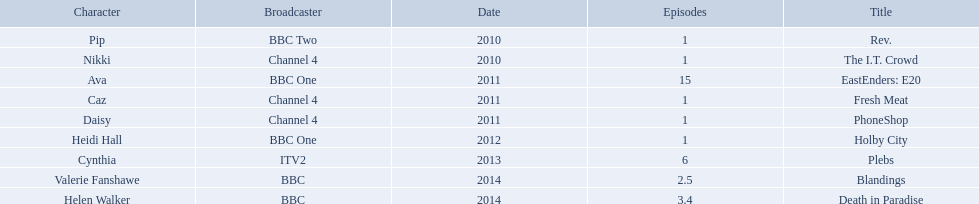What roles did she play? Pip, Nikki, Ava, Caz, Daisy, Heidi Hall, Cynthia, Valerie Fanshawe, Helen Walker. On which broadcasters? BBC Two, Channel 4, BBC One, Channel 4, Channel 4, BBC One, ITV2, BBC, BBC. Which roles did she play for itv2? Cynthia. 